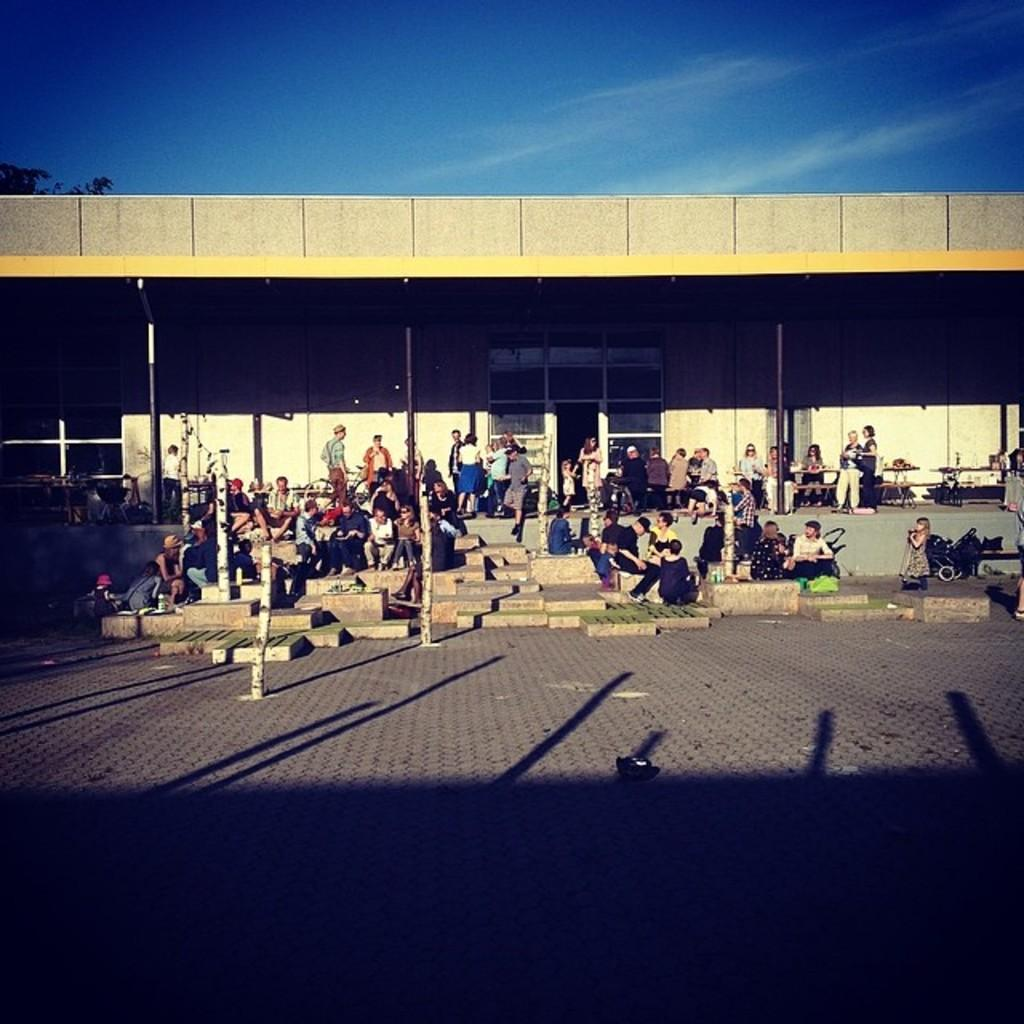What type of structure is visible in the image? There is a roof with poles in the image. What are the people in the image doing? There are people sitting and standing in the image. What type of arch can be seen in the image? There is no arch present in the image; it features a roof with poles and people sitting and standing. What is the profit margin of the business in the image? There is no indication of a business or profit margin in the image. 